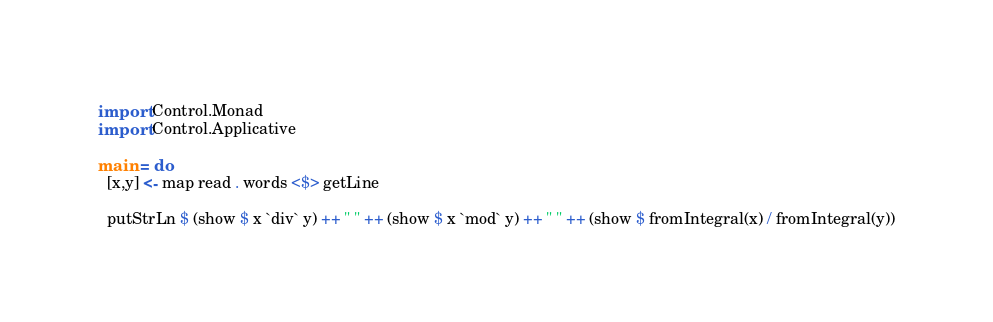<code> <loc_0><loc_0><loc_500><loc_500><_Haskell_>import Control.Monad
import Control.Applicative

main = do
  [x,y] <- map read . words <$> getLine

  putStrLn $ (show $ x `div` y) ++ " " ++ (show $ x `mod` y) ++ " " ++ (show $ fromIntegral(x) / fromIntegral(y))</code> 